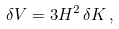<formula> <loc_0><loc_0><loc_500><loc_500>\delta V = 3 H ^ { 2 } \, \delta K \, ,</formula> 